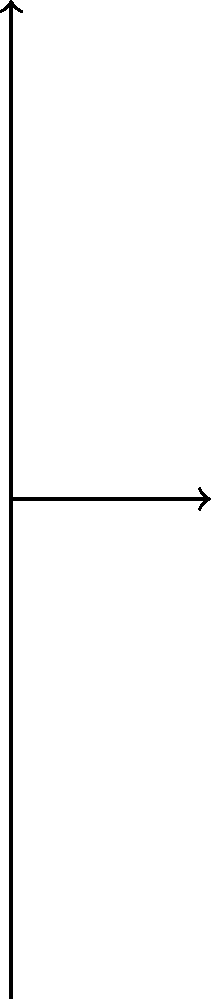A slender column with a length of 5 meters is fixed at the bottom and pinned at the top. The column is made of steel with an elastic modulus of 200 GPa and has a moment of inertia of $1 \times 10^{-4} \text{ m}^4$. Using Euler's formula, determine the critical buckling load for this column. To determine the critical buckling load using Euler's formula, we follow these steps:

1. Identify the given parameters:
   - Length (L) = 5 m
   - Elastic modulus (E) = 200 GPa = $200 \times 10^9$ Pa
   - Moment of inertia (I) = $1 \times 10^{-4} \text{ m}^4$

2. Determine the effective length factor (K) for a column fixed at the bottom and pinned at the top:
   K = 0.699

3. Apply Euler's formula for critical buckling load:
   $$P_{cr} = \frac{\pi^2 EI}{(KL)^2}$$

4. Substitute the values into the formula:
   $$P_{cr} = \frac{\pi^2 \cdot (200 \times 10^9) \cdot (1 \times 10^{-4})}{(0.699 \cdot 5)^2}$$

5. Calculate the result:
   $$P_{cr} = \frac{19.7392 \times 10^5}{12.25225} = 1.61107 \times 10^6 \text{ N}$$

6. Round to three significant figures:
   $$P_{cr} \approx 1.61 \times 10^6 \text{ N} = 1.61 \text{ MN}$$
Answer: 1.61 MN 